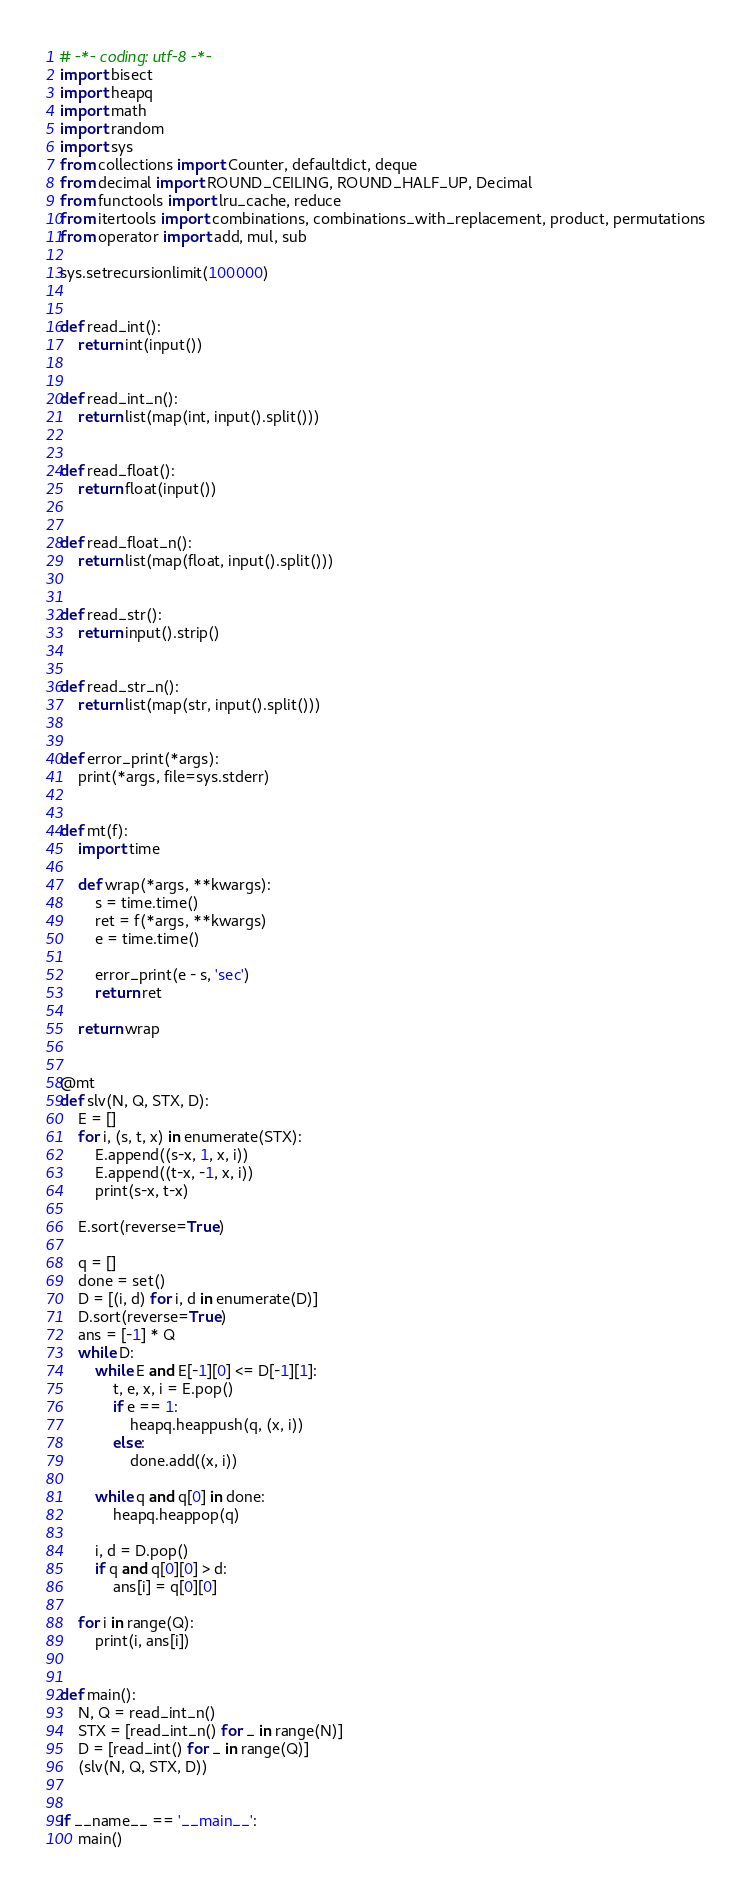<code> <loc_0><loc_0><loc_500><loc_500><_Python_># -*- coding: utf-8 -*-
import bisect
import heapq
import math
import random
import sys
from collections import Counter, defaultdict, deque
from decimal import ROUND_CEILING, ROUND_HALF_UP, Decimal
from functools import lru_cache, reduce
from itertools import combinations, combinations_with_replacement, product, permutations
from operator import add, mul, sub

sys.setrecursionlimit(100000)


def read_int():
    return int(input())


def read_int_n():
    return list(map(int, input().split()))


def read_float():
    return float(input())


def read_float_n():
    return list(map(float, input().split()))


def read_str():
    return input().strip()


def read_str_n():
    return list(map(str, input().split()))


def error_print(*args):
    print(*args, file=sys.stderr)


def mt(f):
    import time

    def wrap(*args, **kwargs):
        s = time.time()
        ret = f(*args, **kwargs)
        e = time.time()

        error_print(e - s, 'sec')
        return ret

    return wrap


@mt
def slv(N, Q, STX, D):
    E = []
    for i, (s, t, x) in enumerate(STX):
        E.append((s-x, 1, x, i))
        E.append((t-x, -1, x, i))
        print(s-x, t-x)

    E.sort(reverse=True)

    q = []
    done = set()
    D = [(i, d) for i, d in enumerate(D)]
    D.sort(reverse=True)
    ans = [-1] * Q
    while D:
        while E and E[-1][0] <= D[-1][1]:
            t, e, x, i = E.pop()
            if e == 1:
                heapq.heappush(q, (x, i))
            else:
                done.add((x, i))

        while q and q[0] in done:
            heapq.heappop(q)

        i, d = D.pop()
        if q and q[0][0] > d:
            ans[i] = q[0][0]

    for i in range(Q):
        print(i, ans[i])


def main():
    N, Q = read_int_n()
    STX = [read_int_n() for _ in range(N)]
    D = [read_int() for _ in range(Q)]
    (slv(N, Q, STX, D))


if __name__ == '__main__':
    main()
</code> 